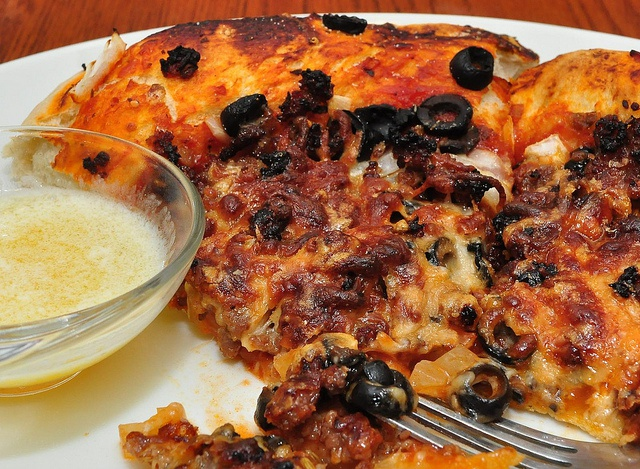Describe the objects in this image and their specific colors. I can see pizza in brown, maroon, black, and red tones, bowl in brown, khaki, tan, and red tones, and fork in brown, darkgray, gray, and tan tones in this image. 